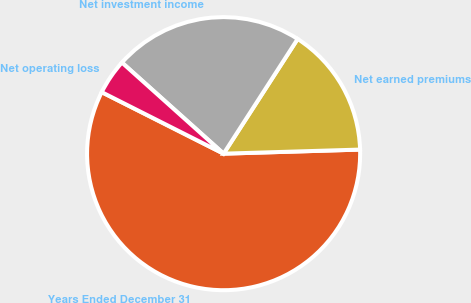Convert chart to OTSL. <chart><loc_0><loc_0><loc_500><loc_500><pie_chart><fcel>Years Ended December 31<fcel>Net earned premiums<fcel>Net investment income<fcel>Net operating loss<nl><fcel>57.91%<fcel>15.4%<fcel>22.49%<fcel>4.19%<nl></chart> 